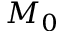Convert formula to latex. <formula><loc_0><loc_0><loc_500><loc_500>M _ { 0 }</formula> 